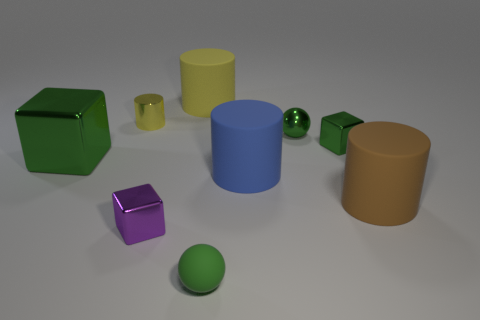Which objects in the image are spherical, and what colors are they? In the image, there are two spherical objects. One is small and green, and the other is larger with a purple hue. 